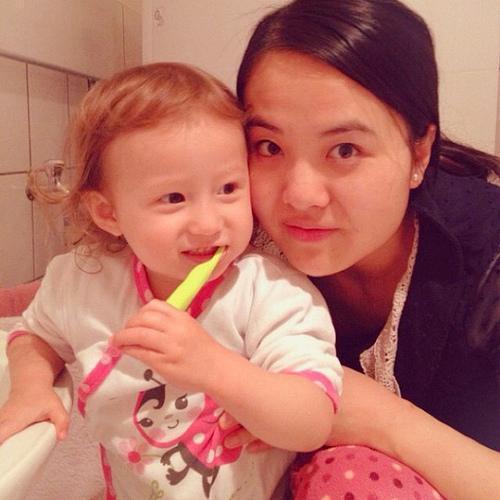How many people have a toothbrush in their mouths?
Give a very brief answer. 1. 